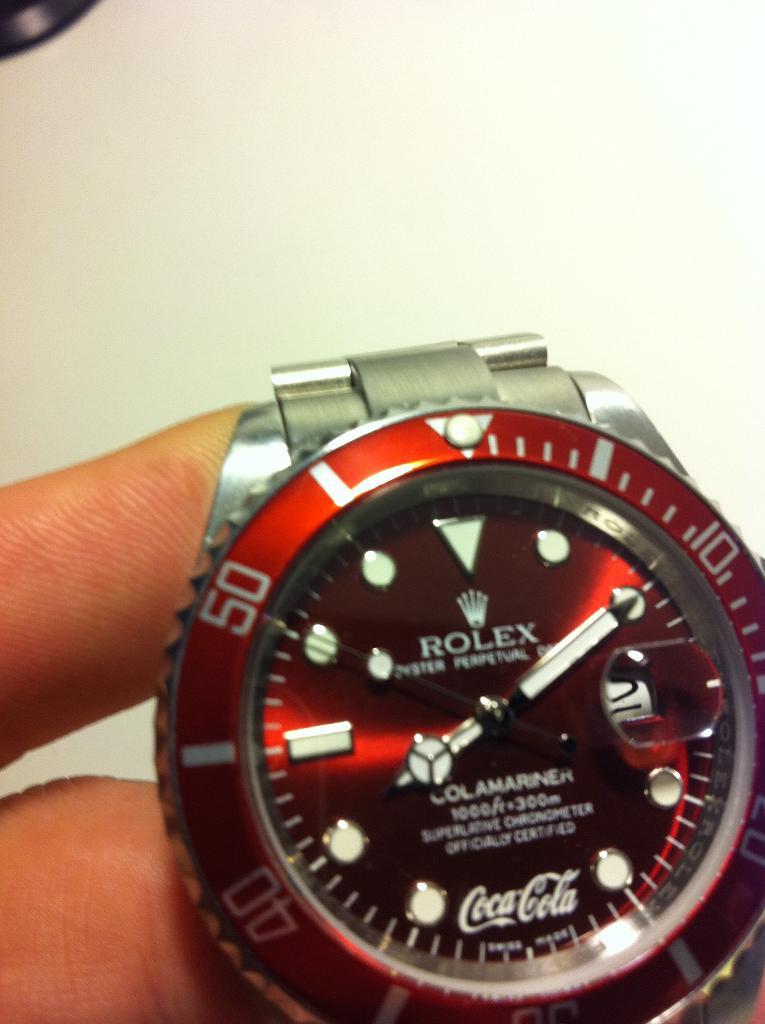Which beverage company is featured on the watch?
Give a very brief answer. Coca cola. Which well known brand is the creator of this watch?
Keep it short and to the point. Rolex. 